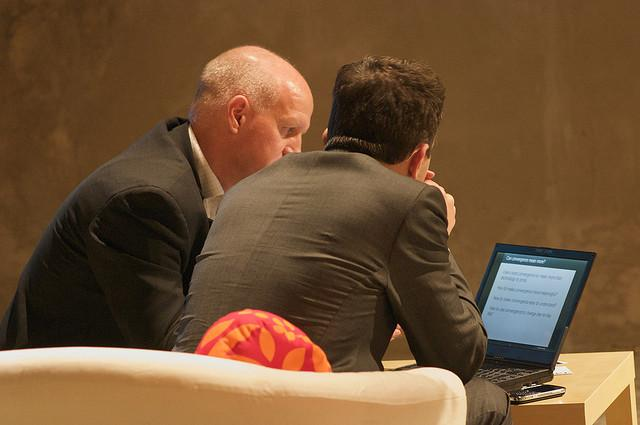What type of battery is best for laptop?

Choices:
A) nimh
B) peds
C) lithium-ion
D) nicad nimh 